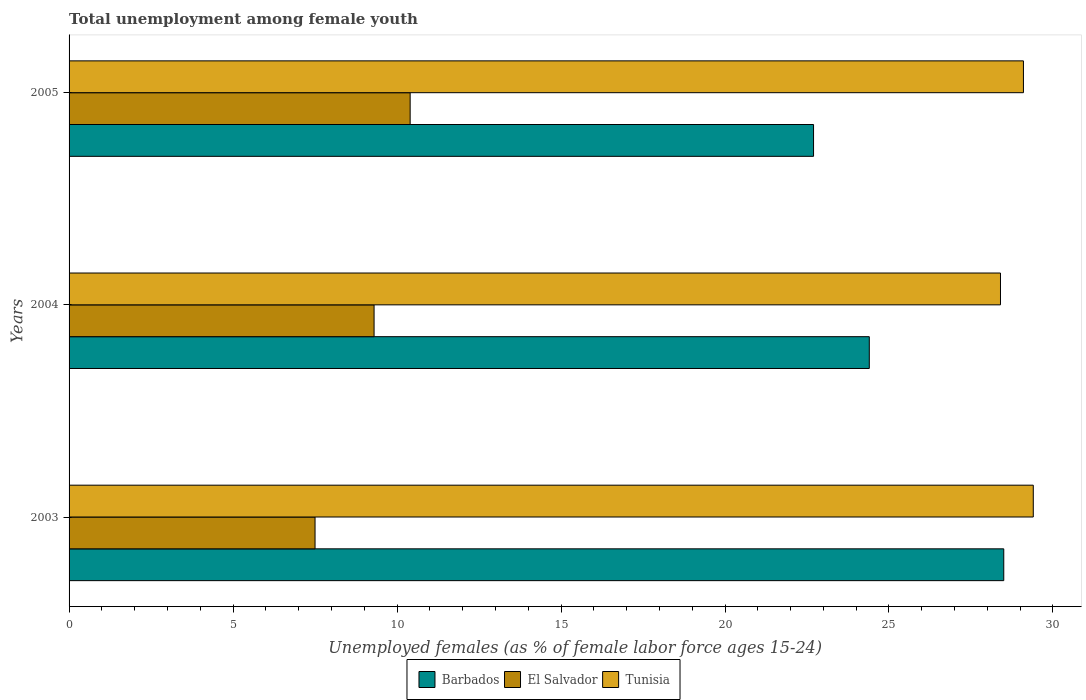How many different coloured bars are there?
Provide a short and direct response. 3. How many bars are there on the 3rd tick from the top?
Provide a short and direct response. 3. How many bars are there on the 1st tick from the bottom?
Provide a short and direct response. 3. What is the label of the 2nd group of bars from the top?
Ensure brevity in your answer.  2004. What is the percentage of unemployed females in in Tunisia in 2003?
Offer a terse response. 29.4. Across all years, what is the maximum percentage of unemployed females in in Barbados?
Your response must be concise. 28.5. Across all years, what is the minimum percentage of unemployed females in in El Salvador?
Provide a succinct answer. 7.5. In which year was the percentage of unemployed females in in Barbados minimum?
Make the answer very short. 2005. What is the total percentage of unemployed females in in Barbados in the graph?
Your answer should be very brief. 75.6. What is the difference between the percentage of unemployed females in in Tunisia in 2003 and that in 2004?
Offer a very short reply. 1. What is the difference between the percentage of unemployed females in in Tunisia in 2004 and the percentage of unemployed females in in Barbados in 2003?
Give a very brief answer. -0.1. What is the average percentage of unemployed females in in Tunisia per year?
Your answer should be very brief. 28.97. In the year 2005, what is the difference between the percentage of unemployed females in in Tunisia and percentage of unemployed females in in El Salvador?
Ensure brevity in your answer.  18.7. In how many years, is the percentage of unemployed females in in Barbados greater than 15 %?
Offer a very short reply. 3. What is the ratio of the percentage of unemployed females in in Tunisia in 2003 to that in 2005?
Ensure brevity in your answer.  1.01. What is the difference between the highest and the second highest percentage of unemployed females in in Barbados?
Make the answer very short. 4.1. What is the difference between the highest and the lowest percentage of unemployed females in in Tunisia?
Provide a succinct answer. 1. Is the sum of the percentage of unemployed females in in Tunisia in 2003 and 2004 greater than the maximum percentage of unemployed females in in El Salvador across all years?
Your answer should be compact. Yes. What does the 3rd bar from the top in 2003 represents?
Offer a terse response. Barbados. What does the 2nd bar from the bottom in 2004 represents?
Make the answer very short. El Salvador. Is it the case that in every year, the sum of the percentage of unemployed females in in Tunisia and percentage of unemployed females in in Barbados is greater than the percentage of unemployed females in in El Salvador?
Keep it short and to the point. Yes. What is the difference between two consecutive major ticks on the X-axis?
Offer a very short reply. 5. Where does the legend appear in the graph?
Your response must be concise. Bottom center. How many legend labels are there?
Keep it short and to the point. 3. What is the title of the graph?
Ensure brevity in your answer.  Total unemployment among female youth. Does "Latin America(all income levels)" appear as one of the legend labels in the graph?
Offer a terse response. No. What is the label or title of the X-axis?
Your response must be concise. Unemployed females (as % of female labor force ages 15-24). What is the Unemployed females (as % of female labor force ages 15-24) in Barbados in 2003?
Provide a succinct answer. 28.5. What is the Unemployed females (as % of female labor force ages 15-24) in El Salvador in 2003?
Your answer should be compact. 7.5. What is the Unemployed females (as % of female labor force ages 15-24) of Tunisia in 2003?
Give a very brief answer. 29.4. What is the Unemployed females (as % of female labor force ages 15-24) of Barbados in 2004?
Make the answer very short. 24.4. What is the Unemployed females (as % of female labor force ages 15-24) of El Salvador in 2004?
Provide a short and direct response. 9.3. What is the Unemployed females (as % of female labor force ages 15-24) in Tunisia in 2004?
Your answer should be very brief. 28.4. What is the Unemployed females (as % of female labor force ages 15-24) of Barbados in 2005?
Provide a short and direct response. 22.7. What is the Unemployed females (as % of female labor force ages 15-24) of El Salvador in 2005?
Offer a terse response. 10.4. What is the Unemployed females (as % of female labor force ages 15-24) of Tunisia in 2005?
Make the answer very short. 29.1. Across all years, what is the maximum Unemployed females (as % of female labor force ages 15-24) in El Salvador?
Keep it short and to the point. 10.4. Across all years, what is the maximum Unemployed females (as % of female labor force ages 15-24) in Tunisia?
Your answer should be very brief. 29.4. Across all years, what is the minimum Unemployed females (as % of female labor force ages 15-24) in Barbados?
Offer a terse response. 22.7. Across all years, what is the minimum Unemployed females (as % of female labor force ages 15-24) in Tunisia?
Give a very brief answer. 28.4. What is the total Unemployed females (as % of female labor force ages 15-24) in Barbados in the graph?
Your response must be concise. 75.6. What is the total Unemployed females (as % of female labor force ages 15-24) of El Salvador in the graph?
Your answer should be very brief. 27.2. What is the total Unemployed females (as % of female labor force ages 15-24) of Tunisia in the graph?
Provide a short and direct response. 86.9. What is the difference between the Unemployed females (as % of female labor force ages 15-24) in Barbados in 2003 and that in 2004?
Your answer should be compact. 4.1. What is the difference between the Unemployed females (as % of female labor force ages 15-24) in Barbados in 2003 and that in 2005?
Provide a short and direct response. 5.8. What is the difference between the Unemployed females (as % of female labor force ages 15-24) in El Salvador in 2003 and that in 2005?
Ensure brevity in your answer.  -2.9. What is the difference between the Unemployed females (as % of female labor force ages 15-24) of Tunisia in 2003 and that in 2005?
Keep it short and to the point. 0.3. What is the difference between the Unemployed females (as % of female labor force ages 15-24) of El Salvador in 2004 and that in 2005?
Make the answer very short. -1.1. What is the difference between the Unemployed females (as % of female labor force ages 15-24) in Tunisia in 2004 and that in 2005?
Offer a terse response. -0.7. What is the difference between the Unemployed females (as % of female labor force ages 15-24) in Barbados in 2003 and the Unemployed females (as % of female labor force ages 15-24) in El Salvador in 2004?
Provide a short and direct response. 19.2. What is the difference between the Unemployed females (as % of female labor force ages 15-24) in El Salvador in 2003 and the Unemployed females (as % of female labor force ages 15-24) in Tunisia in 2004?
Keep it short and to the point. -20.9. What is the difference between the Unemployed females (as % of female labor force ages 15-24) in El Salvador in 2003 and the Unemployed females (as % of female labor force ages 15-24) in Tunisia in 2005?
Ensure brevity in your answer.  -21.6. What is the difference between the Unemployed females (as % of female labor force ages 15-24) in El Salvador in 2004 and the Unemployed females (as % of female labor force ages 15-24) in Tunisia in 2005?
Offer a terse response. -19.8. What is the average Unemployed females (as % of female labor force ages 15-24) in Barbados per year?
Make the answer very short. 25.2. What is the average Unemployed females (as % of female labor force ages 15-24) of El Salvador per year?
Give a very brief answer. 9.07. What is the average Unemployed females (as % of female labor force ages 15-24) in Tunisia per year?
Provide a short and direct response. 28.97. In the year 2003, what is the difference between the Unemployed females (as % of female labor force ages 15-24) of Barbados and Unemployed females (as % of female labor force ages 15-24) of Tunisia?
Your answer should be very brief. -0.9. In the year 2003, what is the difference between the Unemployed females (as % of female labor force ages 15-24) in El Salvador and Unemployed females (as % of female labor force ages 15-24) in Tunisia?
Provide a short and direct response. -21.9. In the year 2004, what is the difference between the Unemployed females (as % of female labor force ages 15-24) of Barbados and Unemployed females (as % of female labor force ages 15-24) of Tunisia?
Your response must be concise. -4. In the year 2004, what is the difference between the Unemployed females (as % of female labor force ages 15-24) in El Salvador and Unemployed females (as % of female labor force ages 15-24) in Tunisia?
Your answer should be compact. -19.1. In the year 2005, what is the difference between the Unemployed females (as % of female labor force ages 15-24) of Barbados and Unemployed females (as % of female labor force ages 15-24) of Tunisia?
Provide a succinct answer. -6.4. In the year 2005, what is the difference between the Unemployed females (as % of female labor force ages 15-24) in El Salvador and Unemployed females (as % of female labor force ages 15-24) in Tunisia?
Provide a short and direct response. -18.7. What is the ratio of the Unemployed females (as % of female labor force ages 15-24) in Barbados in 2003 to that in 2004?
Give a very brief answer. 1.17. What is the ratio of the Unemployed females (as % of female labor force ages 15-24) in El Salvador in 2003 to that in 2004?
Your answer should be compact. 0.81. What is the ratio of the Unemployed females (as % of female labor force ages 15-24) of Tunisia in 2003 to that in 2004?
Your response must be concise. 1.04. What is the ratio of the Unemployed females (as % of female labor force ages 15-24) in Barbados in 2003 to that in 2005?
Your answer should be compact. 1.26. What is the ratio of the Unemployed females (as % of female labor force ages 15-24) of El Salvador in 2003 to that in 2005?
Your response must be concise. 0.72. What is the ratio of the Unemployed females (as % of female labor force ages 15-24) in Tunisia in 2003 to that in 2005?
Give a very brief answer. 1.01. What is the ratio of the Unemployed females (as % of female labor force ages 15-24) in Barbados in 2004 to that in 2005?
Give a very brief answer. 1.07. What is the ratio of the Unemployed females (as % of female labor force ages 15-24) of El Salvador in 2004 to that in 2005?
Your response must be concise. 0.89. What is the ratio of the Unemployed females (as % of female labor force ages 15-24) of Tunisia in 2004 to that in 2005?
Your answer should be very brief. 0.98. What is the difference between the highest and the lowest Unemployed females (as % of female labor force ages 15-24) in El Salvador?
Your answer should be very brief. 2.9. What is the difference between the highest and the lowest Unemployed females (as % of female labor force ages 15-24) in Tunisia?
Offer a very short reply. 1. 